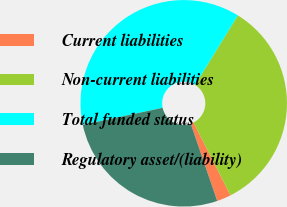Convert chart. <chart><loc_0><loc_0><loc_500><loc_500><pie_chart><fcel>Current liabilities<fcel>Non-current liabilities<fcel>Total funded status<fcel>Regulatory asset/(liability)<nl><fcel>2.23%<fcel>33.74%<fcel>37.12%<fcel>26.9%<nl></chart> 